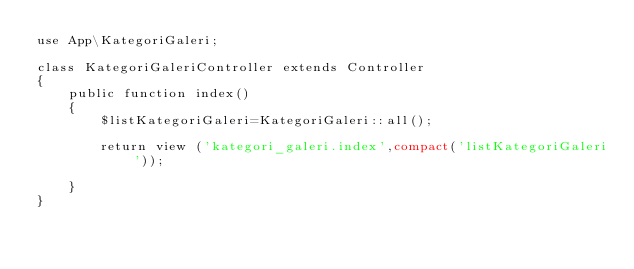Convert code to text. <code><loc_0><loc_0><loc_500><loc_500><_PHP_>use App\KategoriGaleri;

class KategoriGaleriController extends Controller
{
    public function index()
    {
        $listKategoriGaleri=KategoriGaleri::all(); 

    	return view ('kategori_galeri.index',compact('listKategoriGaleri'));

    }
}
</code> 